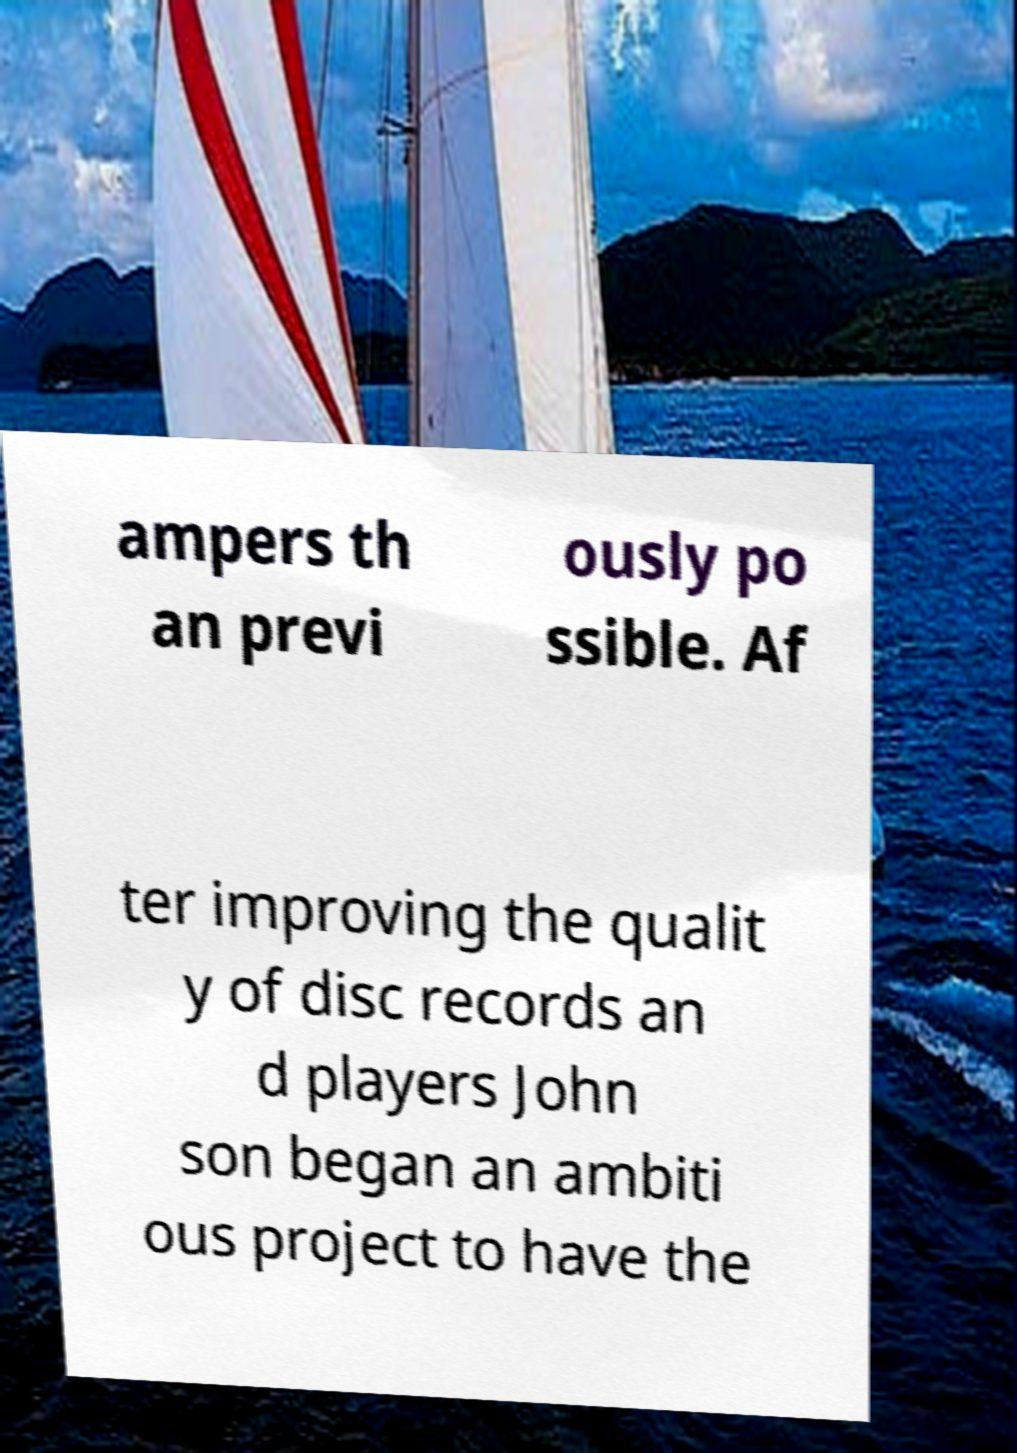For documentation purposes, I need the text within this image transcribed. Could you provide that? ampers th an previ ously po ssible. Af ter improving the qualit y of disc records an d players John son began an ambiti ous project to have the 